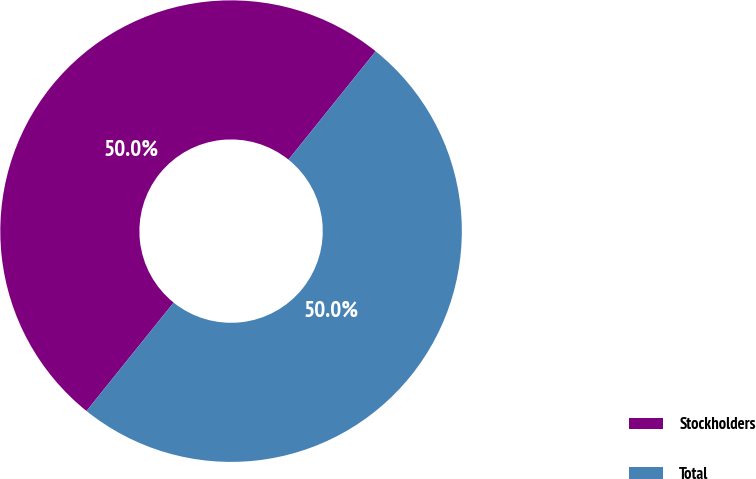Convert chart to OTSL. <chart><loc_0><loc_0><loc_500><loc_500><pie_chart><fcel>Stockholders<fcel>Total<nl><fcel>50.0%<fcel>50.0%<nl></chart> 